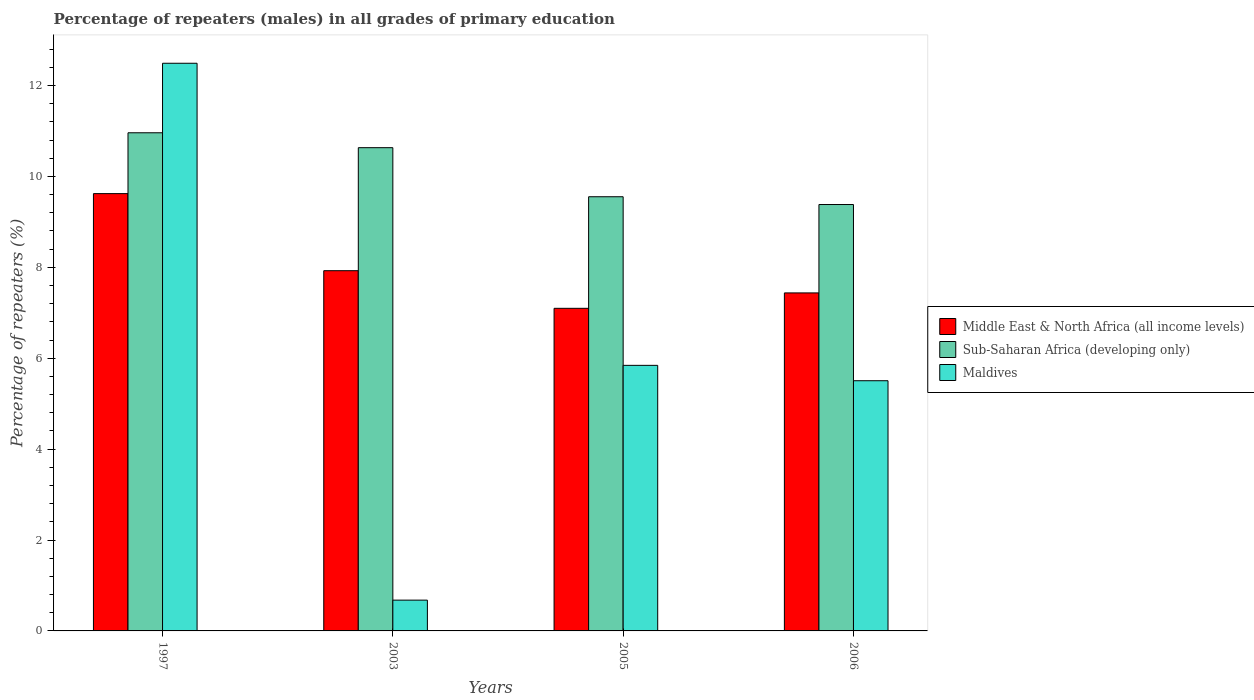How many different coloured bars are there?
Make the answer very short. 3. Are the number of bars on each tick of the X-axis equal?
Make the answer very short. Yes. What is the label of the 3rd group of bars from the left?
Give a very brief answer. 2005. What is the percentage of repeaters (males) in Middle East & North Africa (all income levels) in 2005?
Make the answer very short. 7.1. Across all years, what is the maximum percentage of repeaters (males) in Maldives?
Your response must be concise. 12.49. Across all years, what is the minimum percentage of repeaters (males) in Middle East & North Africa (all income levels)?
Your answer should be very brief. 7.1. In which year was the percentage of repeaters (males) in Middle East & North Africa (all income levels) maximum?
Provide a succinct answer. 1997. In which year was the percentage of repeaters (males) in Sub-Saharan Africa (developing only) minimum?
Offer a terse response. 2006. What is the total percentage of repeaters (males) in Middle East & North Africa (all income levels) in the graph?
Your response must be concise. 32.08. What is the difference between the percentage of repeaters (males) in Middle East & North Africa (all income levels) in 1997 and that in 2003?
Your answer should be compact. 1.7. What is the difference between the percentage of repeaters (males) in Maldives in 2005 and the percentage of repeaters (males) in Sub-Saharan Africa (developing only) in 2006?
Offer a very short reply. -3.54. What is the average percentage of repeaters (males) in Maldives per year?
Your answer should be compact. 6.13. In the year 2006, what is the difference between the percentage of repeaters (males) in Sub-Saharan Africa (developing only) and percentage of repeaters (males) in Maldives?
Ensure brevity in your answer.  3.88. What is the ratio of the percentage of repeaters (males) in Middle East & North Africa (all income levels) in 1997 to that in 2005?
Provide a short and direct response. 1.36. Is the difference between the percentage of repeaters (males) in Sub-Saharan Africa (developing only) in 1997 and 2005 greater than the difference between the percentage of repeaters (males) in Maldives in 1997 and 2005?
Keep it short and to the point. No. What is the difference between the highest and the second highest percentage of repeaters (males) in Sub-Saharan Africa (developing only)?
Your answer should be compact. 0.33. What is the difference between the highest and the lowest percentage of repeaters (males) in Sub-Saharan Africa (developing only)?
Make the answer very short. 1.58. Is the sum of the percentage of repeaters (males) in Middle East & North Africa (all income levels) in 2003 and 2006 greater than the maximum percentage of repeaters (males) in Maldives across all years?
Keep it short and to the point. Yes. What does the 3rd bar from the left in 2005 represents?
Your answer should be very brief. Maldives. What does the 3rd bar from the right in 1997 represents?
Ensure brevity in your answer.  Middle East & North Africa (all income levels). Is it the case that in every year, the sum of the percentage of repeaters (males) in Sub-Saharan Africa (developing only) and percentage of repeaters (males) in Middle East & North Africa (all income levels) is greater than the percentage of repeaters (males) in Maldives?
Your answer should be very brief. Yes. How many years are there in the graph?
Provide a succinct answer. 4. Are the values on the major ticks of Y-axis written in scientific E-notation?
Provide a succinct answer. No. Does the graph contain any zero values?
Provide a succinct answer. No. Where does the legend appear in the graph?
Keep it short and to the point. Center right. How many legend labels are there?
Keep it short and to the point. 3. What is the title of the graph?
Your answer should be very brief. Percentage of repeaters (males) in all grades of primary education. What is the label or title of the Y-axis?
Keep it short and to the point. Percentage of repeaters (%). What is the Percentage of repeaters (%) of Middle East & North Africa (all income levels) in 1997?
Provide a short and direct response. 9.62. What is the Percentage of repeaters (%) in Sub-Saharan Africa (developing only) in 1997?
Provide a succinct answer. 10.96. What is the Percentage of repeaters (%) of Maldives in 1997?
Provide a short and direct response. 12.49. What is the Percentage of repeaters (%) of Middle East & North Africa (all income levels) in 2003?
Provide a succinct answer. 7.93. What is the Percentage of repeaters (%) in Sub-Saharan Africa (developing only) in 2003?
Offer a very short reply. 10.63. What is the Percentage of repeaters (%) of Maldives in 2003?
Your answer should be very brief. 0.68. What is the Percentage of repeaters (%) of Middle East & North Africa (all income levels) in 2005?
Ensure brevity in your answer.  7.1. What is the Percentage of repeaters (%) in Sub-Saharan Africa (developing only) in 2005?
Provide a short and direct response. 9.55. What is the Percentage of repeaters (%) in Maldives in 2005?
Make the answer very short. 5.84. What is the Percentage of repeaters (%) of Middle East & North Africa (all income levels) in 2006?
Give a very brief answer. 7.44. What is the Percentage of repeaters (%) in Sub-Saharan Africa (developing only) in 2006?
Provide a short and direct response. 9.38. What is the Percentage of repeaters (%) in Maldives in 2006?
Your answer should be very brief. 5.5. Across all years, what is the maximum Percentage of repeaters (%) of Middle East & North Africa (all income levels)?
Give a very brief answer. 9.62. Across all years, what is the maximum Percentage of repeaters (%) of Sub-Saharan Africa (developing only)?
Provide a succinct answer. 10.96. Across all years, what is the maximum Percentage of repeaters (%) in Maldives?
Offer a terse response. 12.49. Across all years, what is the minimum Percentage of repeaters (%) in Middle East & North Africa (all income levels)?
Your answer should be very brief. 7.1. Across all years, what is the minimum Percentage of repeaters (%) of Sub-Saharan Africa (developing only)?
Offer a very short reply. 9.38. Across all years, what is the minimum Percentage of repeaters (%) of Maldives?
Ensure brevity in your answer.  0.68. What is the total Percentage of repeaters (%) of Middle East & North Africa (all income levels) in the graph?
Your answer should be very brief. 32.08. What is the total Percentage of repeaters (%) of Sub-Saharan Africa (developing only) in the graph?
Ensure brevity in your answer.  40.53. What is the total Percentage of repeaters (%) of Maldives in the graph?
Offer a very short reply. 24.52. What is the difference between the Percentage of repeaters (%) in Middle East & North Africa (all income levels) in 1997 and that in 2003?
Give a very brief answer. 1.7. What is the difference between the Percentage of repeaters (%) of Sub-Saharan Africa (developing only) in 1997 and that in 2003?
Keep it short and to the point. 0.33. What is the difference between the Percentage of repeaters (%) in Maldives in 1997 and that in 2003?
Offer a very short reply. 11.81. What is the difference between the Percentage of repeaters (%) in Middle East & North Africa (all income levels) in 1997 and that in 2005?
Keep it short and to the point. 2.52. What is the difference between the Percentage of repeaters (%) of Sub-Saharan Africa (developing only) in 1997 and that in 2005?
Keep it short and to the point. 1.41. What is the difference between the Percentage of repeaters (%) of Maldives in 1997 and that in 2005?
Offer a terse response. 6.65. What is the difference between the Percentage of repeaters (%) in Middle East & North Africa (all income levels) in 1997 and that in 2006?
Give a very brief answer. 2.18. What is the difference between the Percentage of repeaters (%) in Sub-Saharan Africa (developing only) in 1997 and that in 2006?
Offer a very short reply. 1.58. What is the difference between the Percentage of repeaters (%) in Maldives in 1997 and that in 2006?
Provide a succinct answer. 6.98. What is the difference between the Percentage of repeaters (%) of Middle East & North Africa (all income levels) in 2003 and that in 2005?
Your response must be concise. 0.83. What is the difference between the Percentage of repeaters (%) in Sub-Saharan Africa (developing only) in 2003 and that in 2005?
Your answer should be compact. 1.08. What is the difference between the Percentage of repeaters (%) of Maldives in 2003 and that in 2005?
Keep it short and to the point. -5.17. What is the difference between the Percentage of repeaters (%) of Middle East & North Africa (all income levels) in 2003 and that in 2006?
Your answer should be compact. 0.49. What is the difference between the Percentage of repeaters (%) in Sub-Saharan Africa (developing only) in 2003 and that in 2006?
Your response must be concise. 1.25. What is the difference between the Percentage of repeaters (%) of Maldives in 2003 and that in 2006?
Your answer should be compact. -4.83. What is the difference between the Percentage of repeaters (%) in Middle East & North Africa (all income levels) in 2005 and that in 2006?
Offer a very short reply. -0.34. What is the difference between the Percentage of repeaters (%) in Sub-Saharan Africa (developing only) in 2005 and that in 2006?
Provide a short and direct response. 0.17. What is the difference between the Percentage of repeaters (%) of Maldives in 2005 and that in 2006?
Your answer should be compact. 0.34. What is the difference between the Percentage of repeaters (%) in Middle East & North Africa (all income levels) in 1997 and the Percentage of repeaters (%) in Sub-Saharan Africa (developing only) in 2003?
Keep it short and to the point. -1.01. What is the difference between the Percentage of repeaters (%) of Middle East & North Africa (all income levels) in 1997 and the Percentage of repeaters (%) of Maldives in 2003?
Provide a succinct answer. 8.94. What is the difference between the Percentage of repeaters (%) in Sub-Saharan Africa (developing only) in 1997 and the Percentage of repeaters (%) in Maldives in 2003?
Give a very brief answer. 10.28. What is the difference between the Percentage of repeaters (%) in Middle East & North Africa (all income levels) in 1997 and the Percentage of repeaters (%) in Sub-Saharan Africa (developing only) in 2005?
Offer a terse response. 0.07. What is the difference between the Percentage of repeaters (%) in Middle East & North Africa (all income levels) in 1997 and the Percentage of repeaters (%) in Maldives in 2005?
Provide a succinct answer. 3.78. What is the difference between the Percentage of repeaters (%) in Sub-Saharan Africa (developing only) in 1997 and the Percentage of repeaters (%) in Maldives in 2005?
Your answer should be very brief. 5.12. What is the difference between the Percentage of repeaters (%) of Middle East & North Africa (all income levels) in 1997 and the Percentage of repeaters (%) of Sub-Saharan Africa (developing only) in 2006?
Offer a very short reply. 0.24. What is the difference between the Percentage of repeaters (%) of Middle East & North Africa (all income levels) in 1997 and the Percentage of repeaters (%) of Maldives in 2006?
Make the answer very short. 4.12. What is the difference between the Percentage of repeaters (%) of Sub-Saharan Africa (developing only) in 1997 and the Percentage of repeaters (%) of Maldives in 2006?
Offer a terse response. 5.46. What is the difference between the Percentage of repeaters (%) of Middle East & North Africa (all income levels) in 2003 and the Percentage of repeaters (%) of Sub-Saharan Africa (developing only) in 2005?
Make the answer very short. -1.63. What is the difference between the Percentage of repeaters (%) of Middle East & North Africa (all income levels) in 2003 and the Percentage of repeaters (%) of Maldives in 2005?
Your response must be concise. 2.08. What is the difference between the Percentage of repeaters (%) of Sub-Saharan Africa (developing only) in 2003 and the Percentage of repeaters (%) of Maldives in 2005?
Your response must be concise. 4.79. What is the difference between the Percentage of repeaters (%) of Middle East & North Africa (all income levels) in 2003 and the Percentage of repeaters (%) of Sub-Saharan Africa (developing only) in 2006?
Offer a very short reply. -1.46. What is the difference between the Percentage of repeaters (%) of Middle East & North Africa (all income levels) in 2003 and the Percentage of repeaters (%) of Maldives in 2006?
Provide a short and direct response. 2.42. What is the difference between the Percentage of repeaters (%) of Sub-Saharan Africa (developing only) in 2003 and the Percentage of repeaters (%) of Maldives in 2006?
Your answer should be very brief. 5.13. What is the difference between the Percentage of repeaters (%) in Middle East & North Africa (all income levels) in 2005 and the Percentage of repeaters (%) in Sub-Saharan Africa (developing only) in 2006?
Your response must be concise. -2.28. What is the difference between the Percentage of repeaters (%) in Middle East & North Africa (all income levels) in 2005 and the Percentage of repeaters (%) in Maldives in 2006?
Your response must be concise. 1.59. What is the difference between the Percentage of repeaters (%) in Sub-Saharan Africa (developing only) in 2005 and the Percentage of repeaters (%) in Maldives in 2006?
Provide a short and direct response. 4.05. What is the average Percentage of repeaters (%) in Middle East & North Africa (all income levels) per year?
Your answer should be very brief. 8.02. What is the average Percentage of repeaters (%) of Sub-Saharan Africa (developing only) per year?
Your response must be concise. 10.13. What is the average Percentage of repeaters (%) in Maldives per year?
Make the answer very short. 6.13. In the year 1997, what is the difference between the Percentage of repeaters (%) in Middle East & North Africa (all income levels) and Percentage of repeaters (%) in Sub-Saharan Africa (developing only)?
Your response must be concise. -1.34. In the year 1997, what is the difference between the Percentage of repeaters (%) of Middle East & North Africa (all income levels) and Percentage of repeaters (%) of Maldives?
Keep it short and to the point. -2.87. In the year 1997, what is the difference between the Percentage of repeaters (%) in Sub-Saharan Africa (developing only) and Percentage of repeaters (%) in Maldives?
Make the answer very short. -1.53. In the year 2003, what is the difference between the Percentage of repeaters (%) in Middle East & North Africa (all income levels) and Percentage of repeaters (%) in Sub-Saharan Africa (developing only)?
Your response must be concise. -2.71. In the year 2003, what is the difference between the Percentage of repeaters (%) in Middle East & North Africa (all income levels) and Percentage of repeaters (%) in Maldives?
Give a very brief answer. 7.25. In the year 2003, what is the difference between the Percentage of repeaters (%) in Sub-Saharan Africa (developing only) and Percentage of repeaters (%) in Maldives?
Your answer should be compact. 9.96. In the year 2005, what is the difference between the Percentage of repeaters (%) in Middle East & North Africa (all income levels) and Percentage of repeaters (%) in Sub-Saharan Africa (developing only)?
Make the answer very short. -2.46. In the year 2005, what is the difference between the Percentage of repeaters (%) of Middle East & North Africa (all income levels) and Percentage of repeaters (%) of Maldives?
Your answer should be compact. 1.25. In the year 2005, what is the difference between the Percentage of repeaters (%) of Sub-Saharan Africa (developing only) and Percentage of repeaters (%) of Maldives?
Keep it short and to the point. 3.71. In the year 2006, what is the difference between the Percentage of repeaters (%) in Middle East & North Africa (all income levels) and Percentage of repeaters (%) in Sub-Saharan Africa (developing only)?
Your answer should be compact. -1.95. In the year 2006, what is the difference between the Percentage of repeaters (%) in Middle East & North Africa (all income levels) and Percentage of repeaters (%) in Maldives?
Keep it short and to the point. 1.93. In the year 2006, what is the difference between the Percentage of repeaters (%) of Sub-Saharan Africa (developing only) and Percentage of repeaters (%) of Maldives?
Your answer should be very brief. 3.88. What is the ratio of the Percentage of repeaters (%) in Middle East & North Africa (all income levels) in 1997 to that in 2003?
Your answer should be compact. 1.21. What is the ratio of the Percentage of repeaters (%) in Sub-Saharan Africa (developing only) in 1997 to that in 2003?
Offer a terse response. 1.03. What is the ratio of the Percentage of repeaters (%) of Maldives in 1997 to that in 2003?
Make the answer very short. 18.44. What is the ratio of the Percentage of repeaters (%) in Middle East & North Africa (all income levels) in 1997 to that in 2005?
Ensure brevity in your answer.  1.36. What is the ratio of the Percentage of repeaters (%) in Sub-Saharan Africa (developing only) in 1997 to that in 2005?
Provide a short and direct response. 1.15. What is the ratio of the Percentage of repeaters (%) in Maldives in 1997 to that in 2005?
Your response must be concise. 2.14. What is the ratio of the Percentage of repeaters (%) in Middle East & North Africa (all income levels) in 1997 to that in 2006?
Ensure brevity in your answer.  1.29. What is the ratio of the Percentage of repeaters (%) in Sub-Saharan Africa (developing only) in 1997 to that in 2006?
Ensure brevity in your answer.  1.17. What is the ratio of the Percentage of repeaters (%) of Maldives in 1997 to that in 2006?
Provide a succinct answer. 2.27. What is the ratio of the Percentage of repeaters (%) of Middle East & North Africa (all income levels) in 2003 to that in 2005?
Offer a terse response. 1.12. What is the ratio of the Percentage of repeaters (%) in Sub-Saharan Africa (developing only) in 2003 to that in 2005?
Provide a short and direct response. 1.11. What is the ratio of the Percentage of repeaters (%) in Maldives in 2003 to that in 2005?
Make the answer very short. 0.12. What is the ratio of the Percentage of repeaters (%) of Middle East & North Africa (all income levels) in 2003 to that in 2006?
Ensure brevity in your answer.  1.07. What is the ratio of the Percentage of repeaters (%) of Sub-Saharan Africa (developing only) in 2003 to that in 2006?
Give a very brief answer. 1.13. What is the ratio of the Percentage of repeaters (%) in Maldives in 2003 to that in 2006?
Your answer should be compact. 0.12. What is the ratio of the Percentage of repeaters (%) of Middle East & North Africa (all income levels) in 2005 to that in 2006?
Provide a short and direct response. 0.95. What is the ratio of the Percentage of repeaters (%) in Sub-Saharan Africa (developing only) in 2005 to that in 2006?
Give a very brief answer. 1.02. What is the ratio of the Percentage of repeaters (%) in Maldives in 2005 to that in 2006?
Give a very brief answer. 1.06. What is the difference between the highest and the second highest Percentage of repeaters (%) in Middle East & North Africa (all income levels)?
Ensure brevity in your answer.  1.7. What is the difference between the highest and the second highest Percentage of repeaters (%) in Sub-Saharan Africa (developing only)?
Provide a short and direct response. 0.33. What is the difference between the highest and the second highest Percentage of repeaters (%) of Maldives?
Provide a succinct answer. 6.65. What is the difference between the highest and the lowest Percentage of repeaters (%) in Middle East & North Africa (all income levels)?
Your answer should be compact. 2.52. What is the difference between the highest and the lowest Percentage of repeaters (%) of Sub-Saharan Africa (developing only)?
Offer a terse response. 1.58. What is the difference between the highest and the lowest Percentage of repeaters (%) of Maldives?
Your answer should be compact. 11.81. 